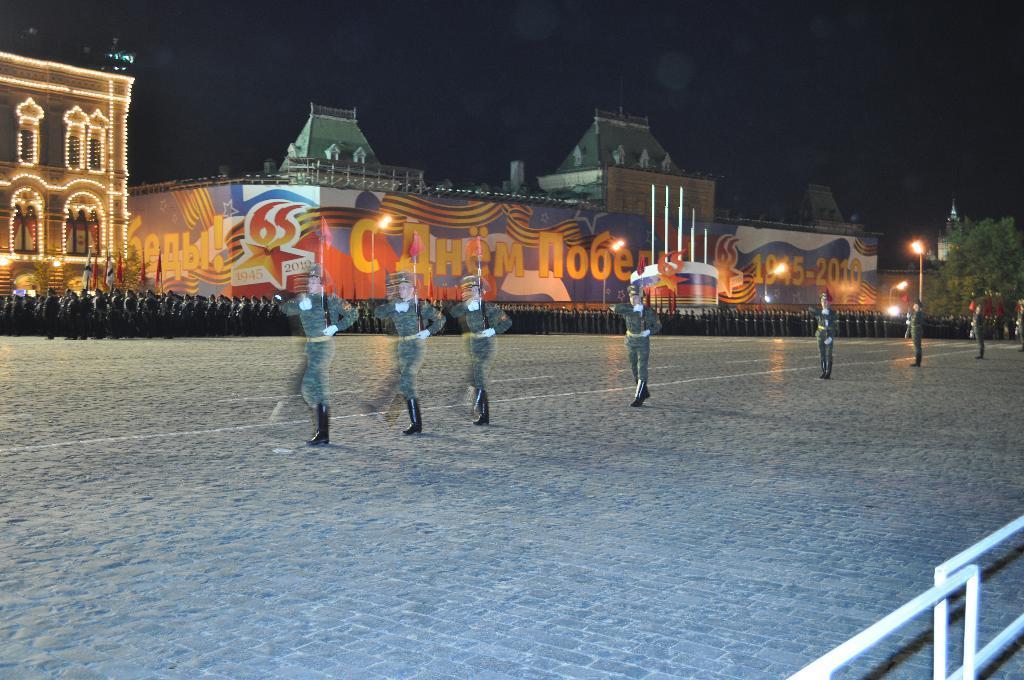Describe this image in one or two sentences. In this image I can see few people wearing the uniforms and holding the weapons. To the right there is a railing. To the left I can see many people. In the background there are buildings with lights. I can also see the trees, lights to the right. In the background there is a sky. 